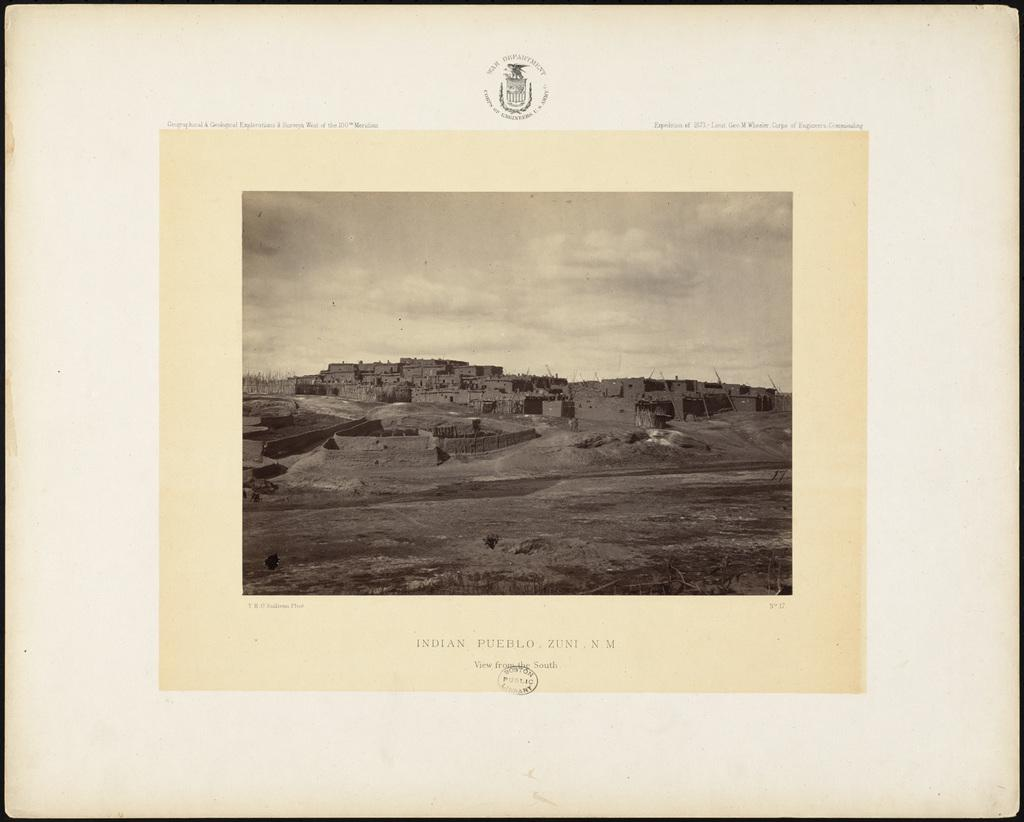<image>
Create a compact narrative representing the image presented. A black and white  photo of a Pueblo village from New Mexico. 